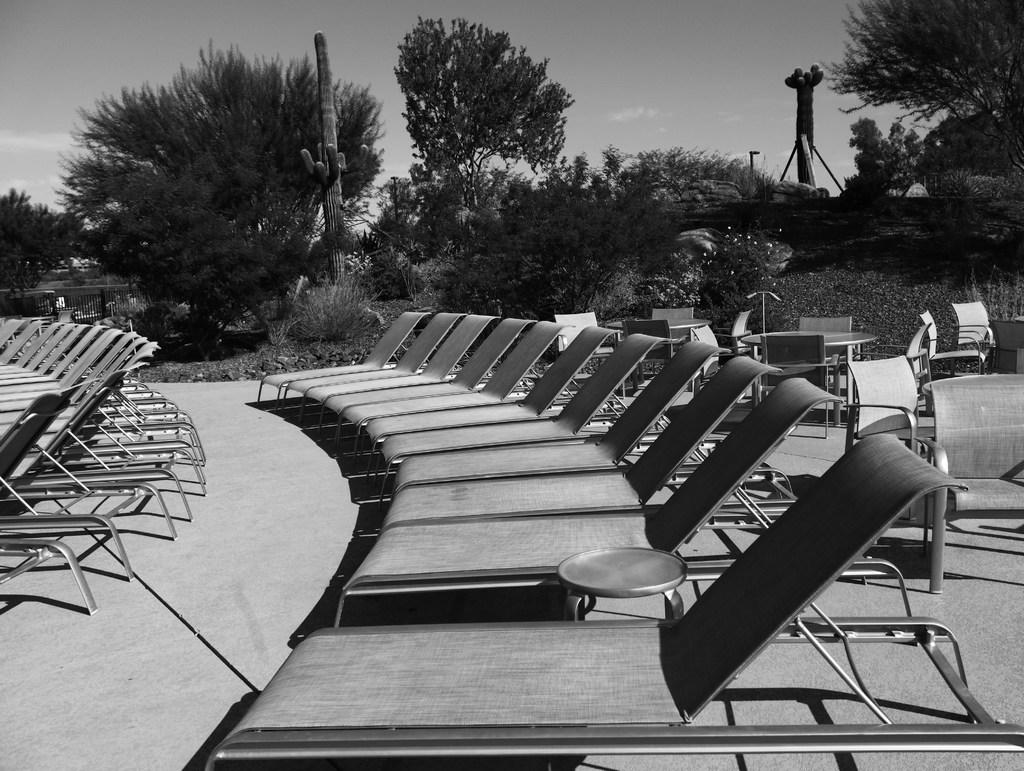What is the color scheme of the image? The image is black and white. What type of furniture is on the floor in the image? There are chaise lounges on the floor. What type of natural elements can be seen in the image? There are trees, plants, and rocks in the image. What is visible in the background of the image? The sky is visible in the image, and clouds are present in the sky. Can you see a mitten being used to play a musical instrument in the image? There is no mitten or musical instrument present in the image. What type of harmony is being created by the elbow in the image? There is no elbow or harmony present in the image. 